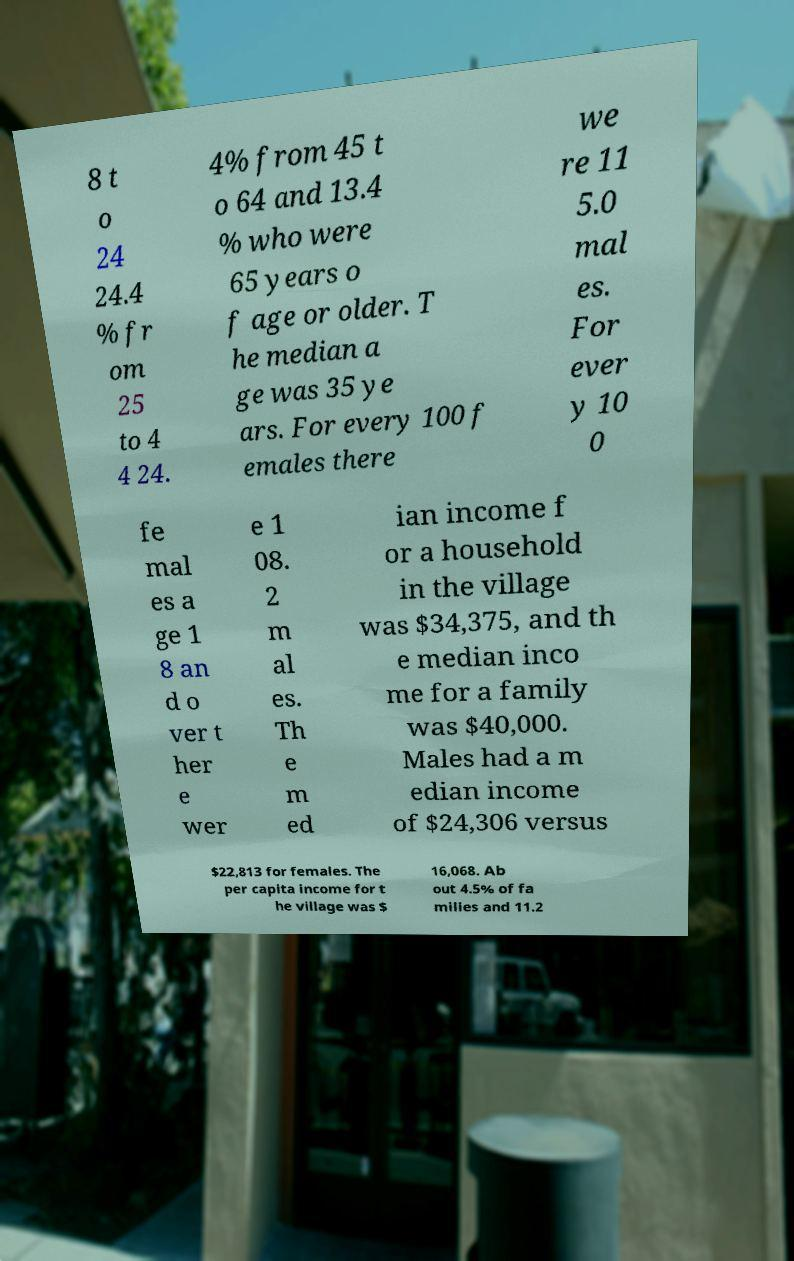Please identify and transcribe the text found in this image. 8 t o 24 24.4 % fr om 25 to 4 4 24. 4% from 45 t o 64 and 13.4 % who were 65 years o f age or older. T he median a ge was 35 ye ars. For every 100 f emales there we re 11 5.0 mal es. For ever y 10 0 fe mal es a ge 1 8 an d o ver t her e wer e 1 08. 2 m al es. Th e m ed ian income f or a household in the village was $34,375, and th e median inco me for a family was $40,000. Males had a m edian income of $24,306 versus $22,813 for females. The per capita income for t he village was $ 16,068. Ab out 4.5% of fa milies and 11.2 